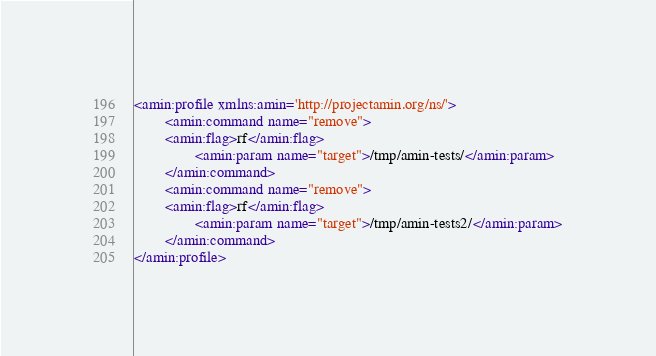Convert code to text. <code><loc_0><loc_0><loc_500><loc_500><_XML_><amin:profile xmlns:amin='http://projectamin.org/ns/'>
        <amin:command name="remove">
		<amin:flag>rf</amin:flag>
                <amin:param name="target">/tmp/amin-tests/</amin:param>
        </amin:command>
        <amin:command name="remove">
		<amin:flag>rf</amin:flag>
                <amin:param name="target">/tmp/amin-tests2/</amin:param>
        </amin:command>
</amin:profile>
</code> 